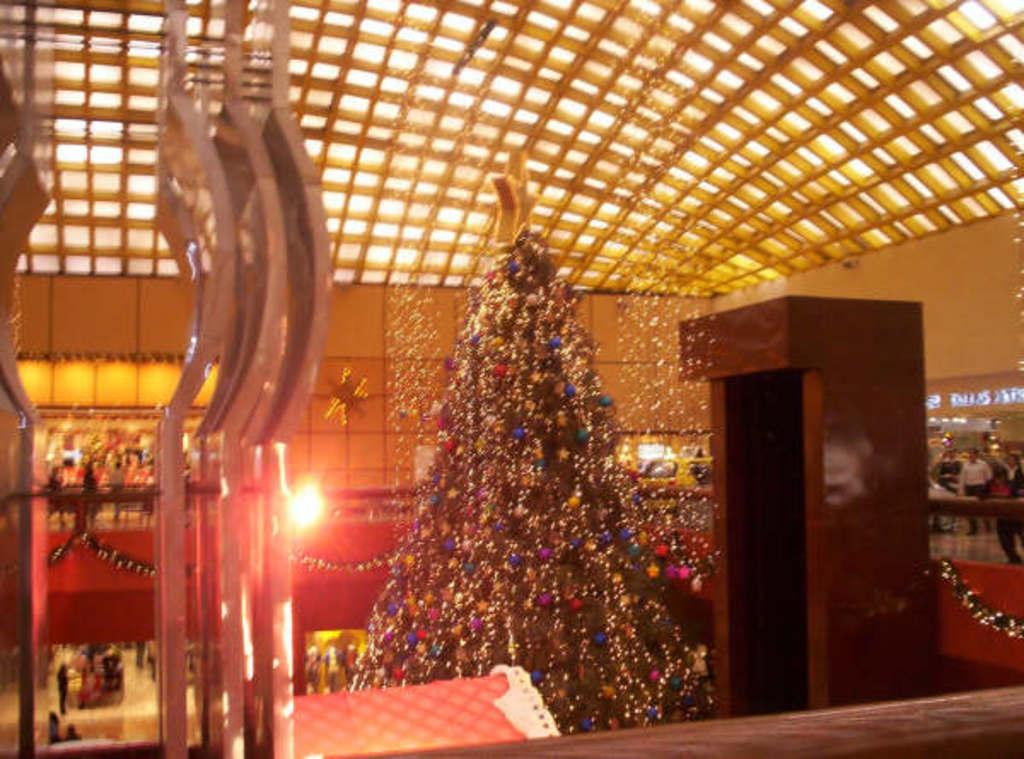What is the main subject in the middle of the image? There is a Christmas tree in the middle of the image. What can be seen in the background of the image? There are lights, vehicles, and a group of people in the background of the image. What type of tank is visible in the image? There is no tank present in the image. How many people are falling in the image? There are no people falling in the image. 